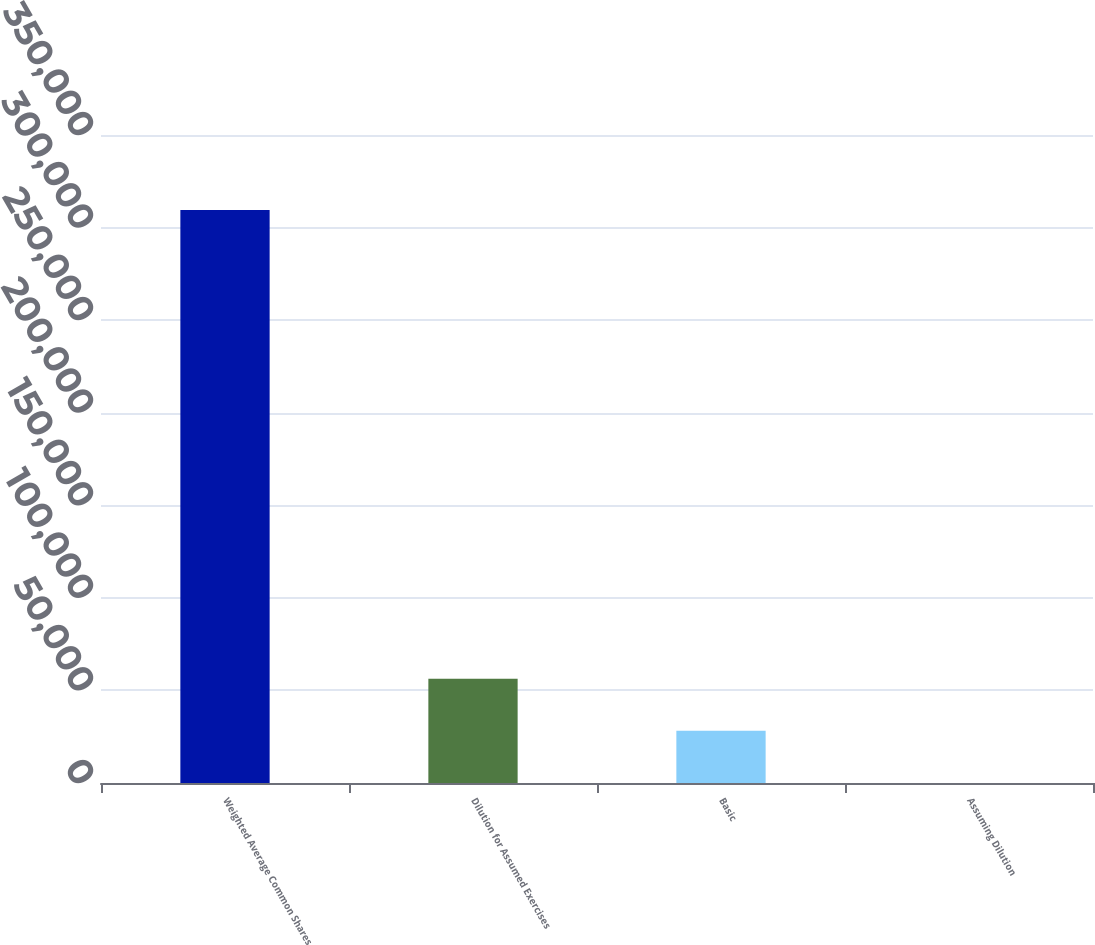<chart> <loc_0><loc_0><loc_500><loc_500><bar_chart><fcel>Weighted Average Common Shares<fcel>Dilution for Assumed Exercises<fcel>Basic<fcel>Assuming Dilution<nl><fcel>309531<fcel>56353.9<fcel>28178.5<fcel>3.17<nl></chart> 